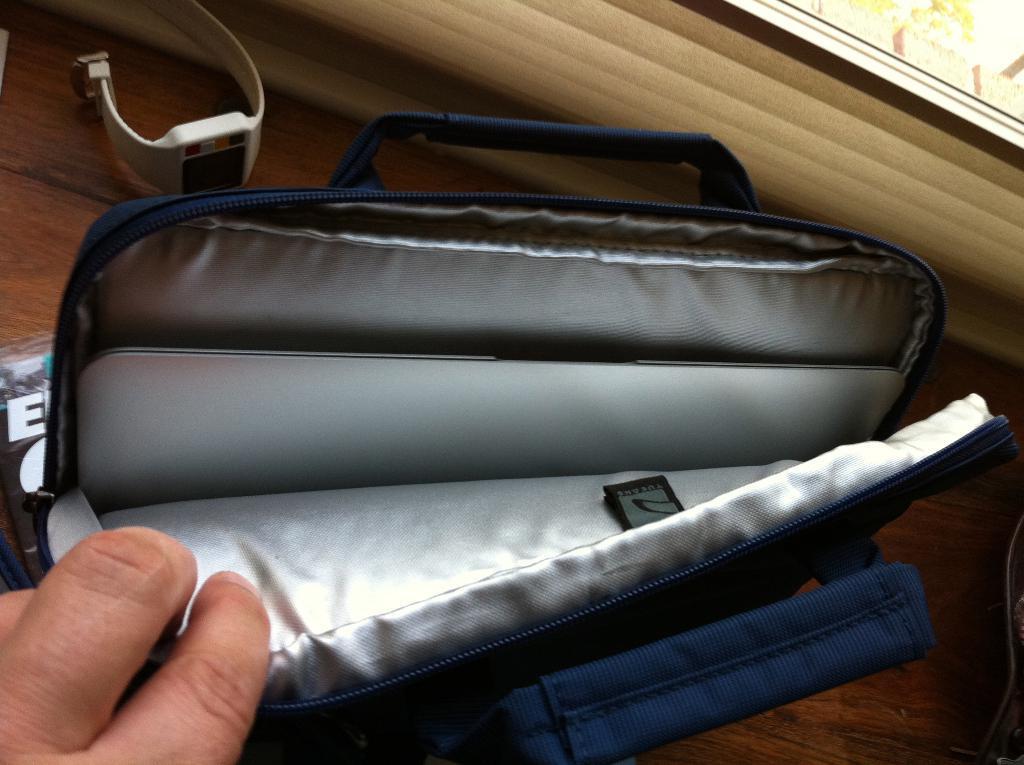How would you summarize this image in a sentence or two? In this picture we can see a person holding a bag. There is a watch on the table. We can see a plant in the background. 